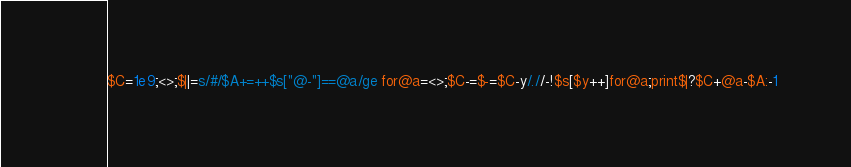<code> <loc_0><loc_0><loc_500><loc_500><_Perl_>$C=1e9;<>;$||=s/#/$A+=++$s["@-"]==@a/ge for@a=<>;$C-=$-=$C-y/.//-!$s[$y++]for@a;print$|?$C+@a-$A:-1</code> 